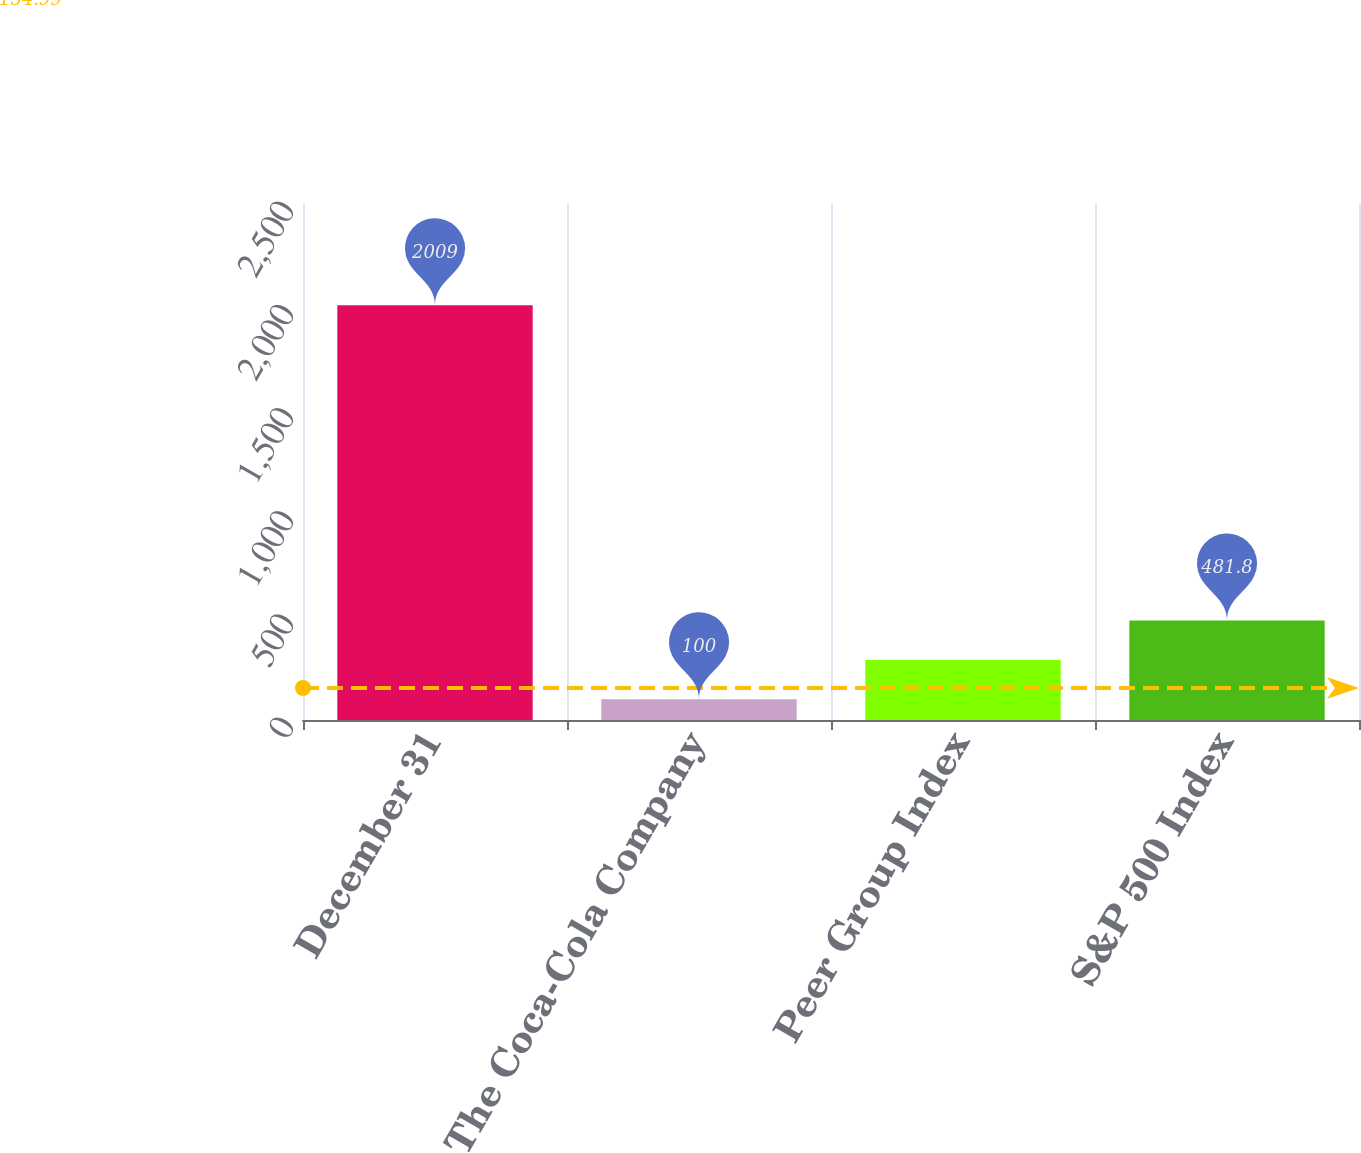Convert chart. <chart><loc_0><loc_0><loc_500><loc_500><bar_chart><fcel>December 31<fcel>The Coca-Cola Company<fcel>Peer Group Index<fcel>S&P 500 Index<nl><fcel>2009<fcel>100<fcel>290.9<fcel>481.8<nl></chart> 